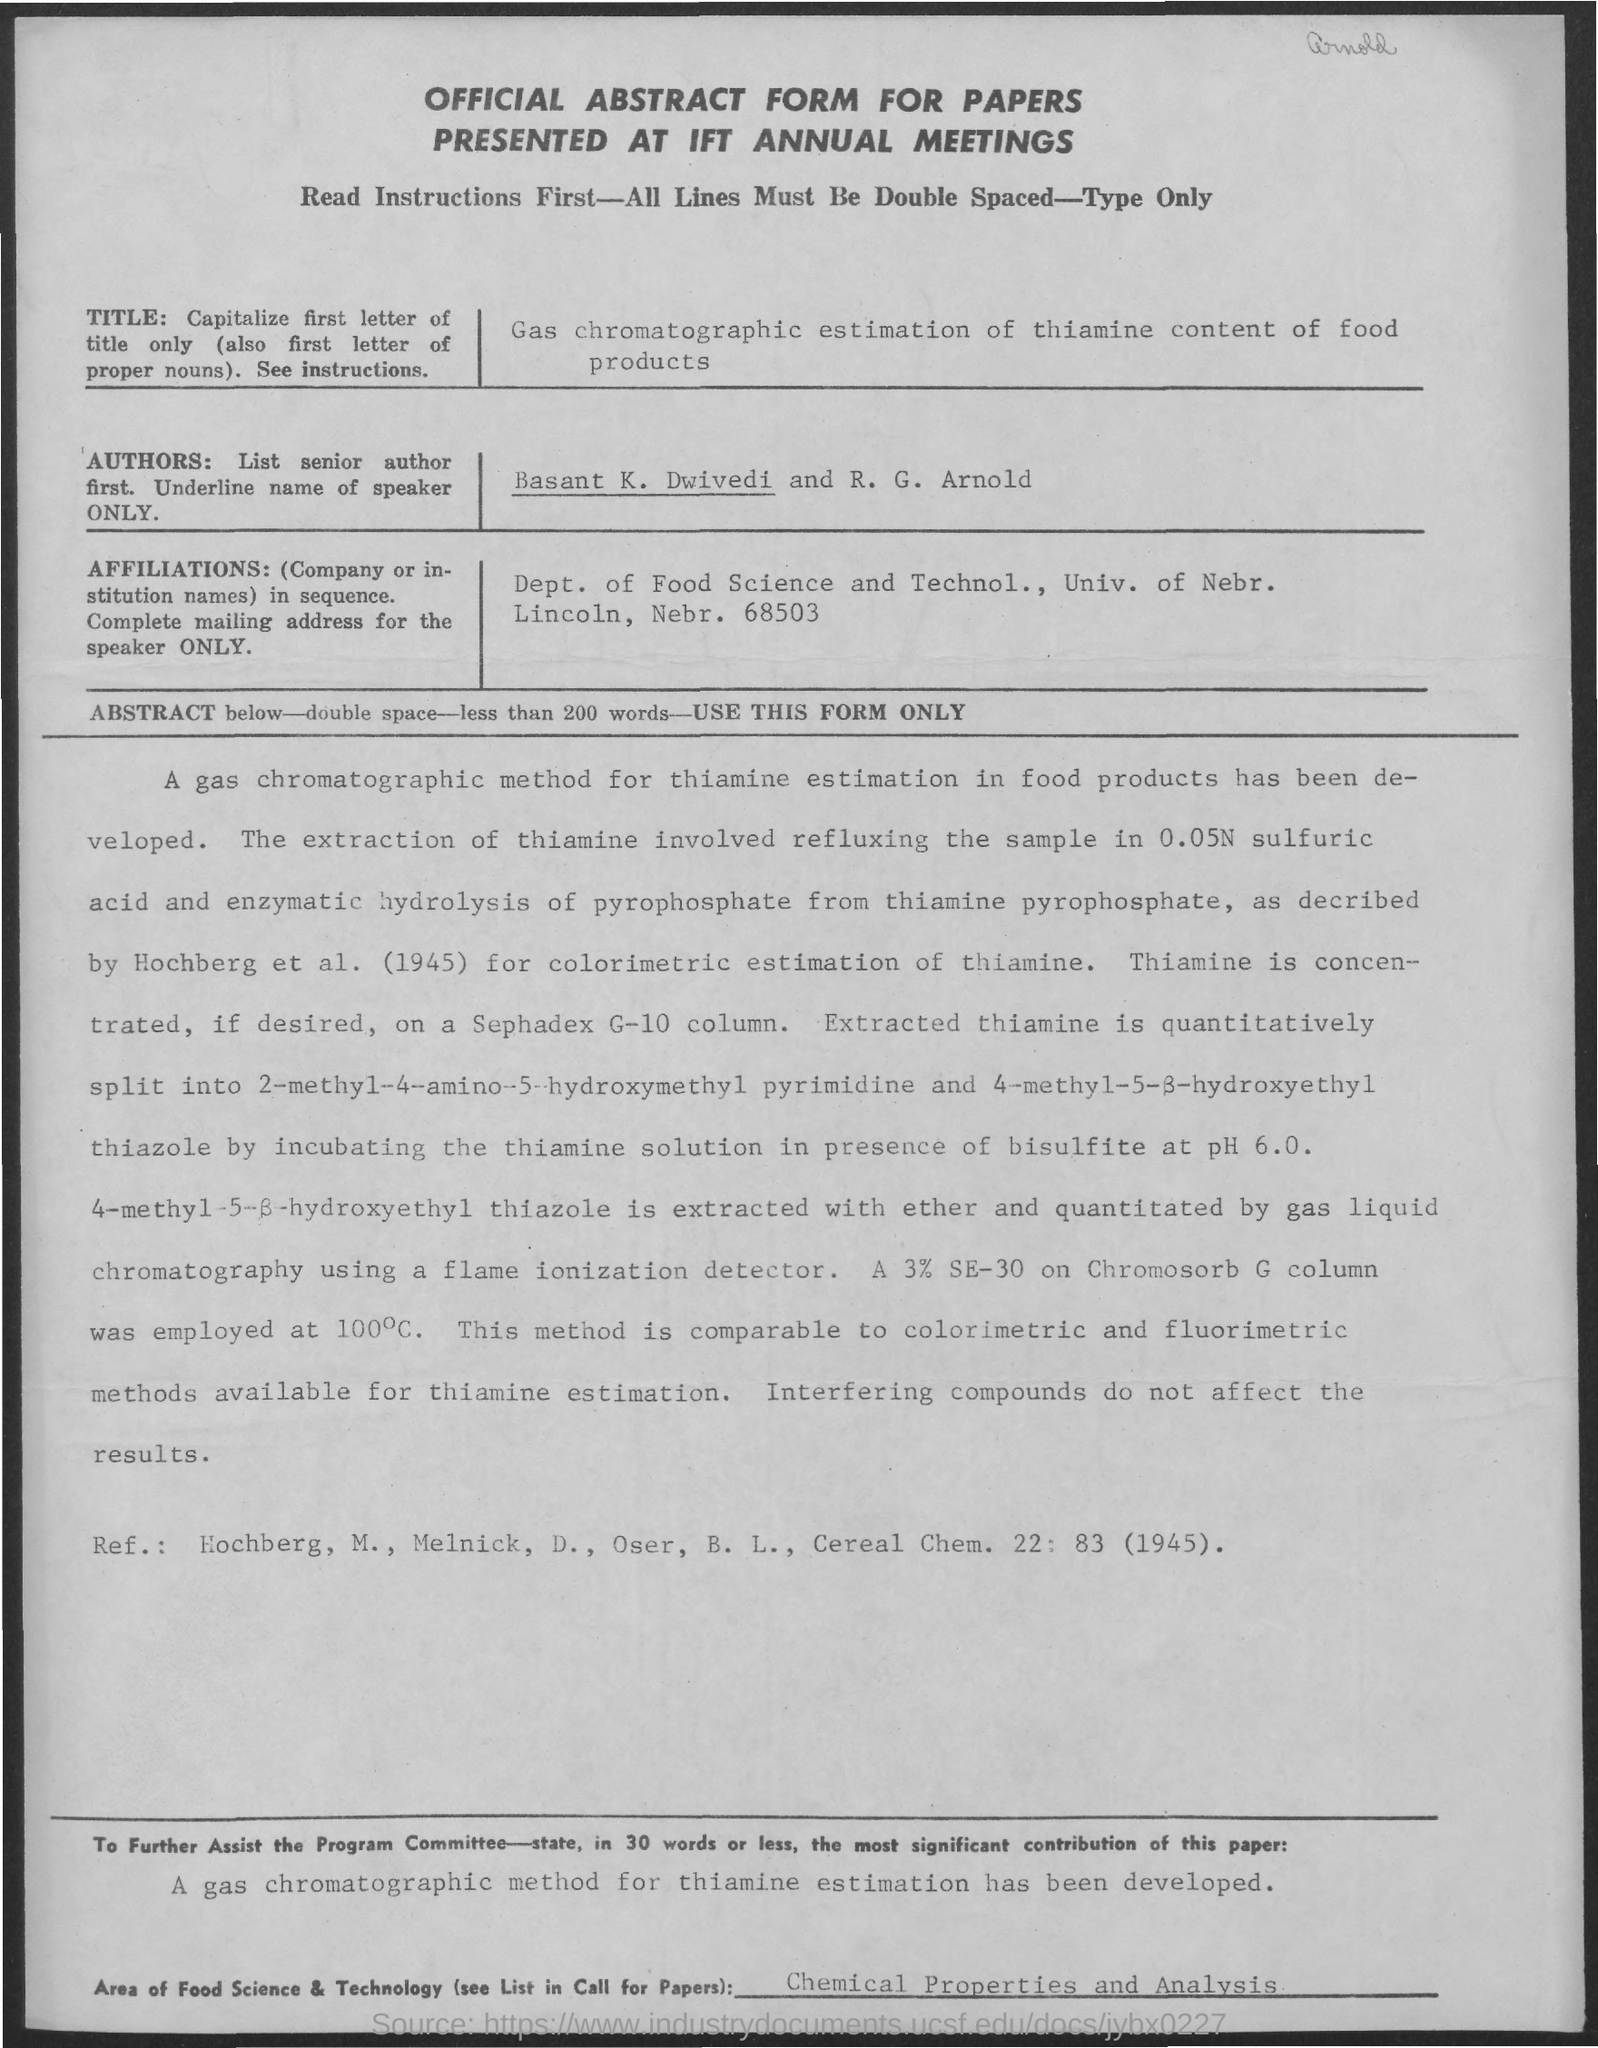What is the document title?
Your answer should be very brief. OFFICIAL ABSTRACT FORM FOR PAPERS PRESENTED AT IFT ANNUAL MEETINGS. What is the title of the paper?
Your answer should be compact. Gas chromatographic estimation of thiamine content of food products. Who are the authors?
Keep it short and to the point. Basant K. Dwivedi and R. G. Arnold. 